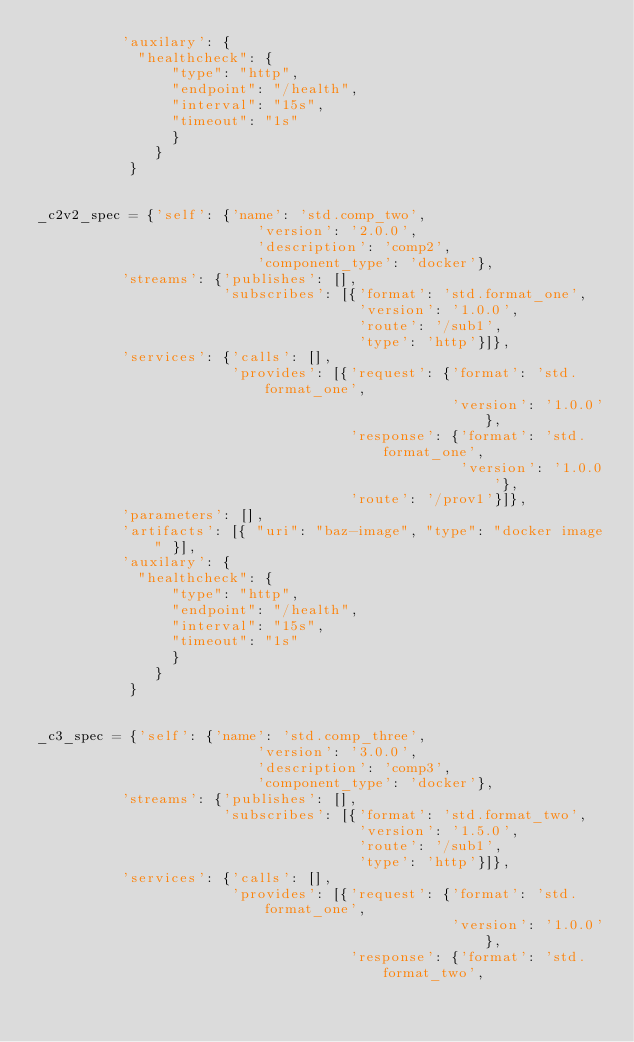<code> <loc_0><loc_0><loc_500><loc_500><_Python_>          'auxilary': {
            "healthcheck": {
                "type": "http",
                "endpoint": "/health",
                "interval": "15s",
                "timeout": "1s"
                }
              }
           }


_c2v2_spec = {'self': {'name': 'std.comp_two',
                          'version': '2.0.0',
                          'description': 'comp2',
                          'component_type': 'docker'},
          'streams': {'publishes': [],
                      'subscribes': [{'format': 'std.format_one',
                                      'version': '1.0.0',
                                      'route': '/sub1',
                                      'type': 'http'}]},
          'services': {'calls': [],
                       'provides': [{'request': {'format': 'std.format_one',
                                                 'version': '1.0.0'},
                                     'response': {'format': 'std.format_one',
                                                  'version': '1.0.0'},
                                     'route': '/prov1'}]},
          'parameters': [],
          'artifacts': [{ "uri": "baz-image", "type": "docker image" }],
          'auxilary': {
            "healthcheck": {
                "type": "http",
                "endpoint": "/health",
                "interval": "15s",
                "timeout": "1s"
                }
              }
           }


_c3_spec = {'self': {'name': 'std.comp_three',
                          'version': '3.0.0',
                          'description': 'comp3',
                          'component_type': 'docker'},
          'streams': {'publishes': [],
                      'subscribes': [{'format': 'std.format_two',
                                      'version': '1.5.0',
                                      'route': '/sub1',
                                      'type': 'http'}]},
          'services': {'calls': [],
                       'provides': [{'request': {'format': 'std.format_one',
                                                 'version': '1.0.0'},
                                     'response': {'format': 'std.format_two',</code> 